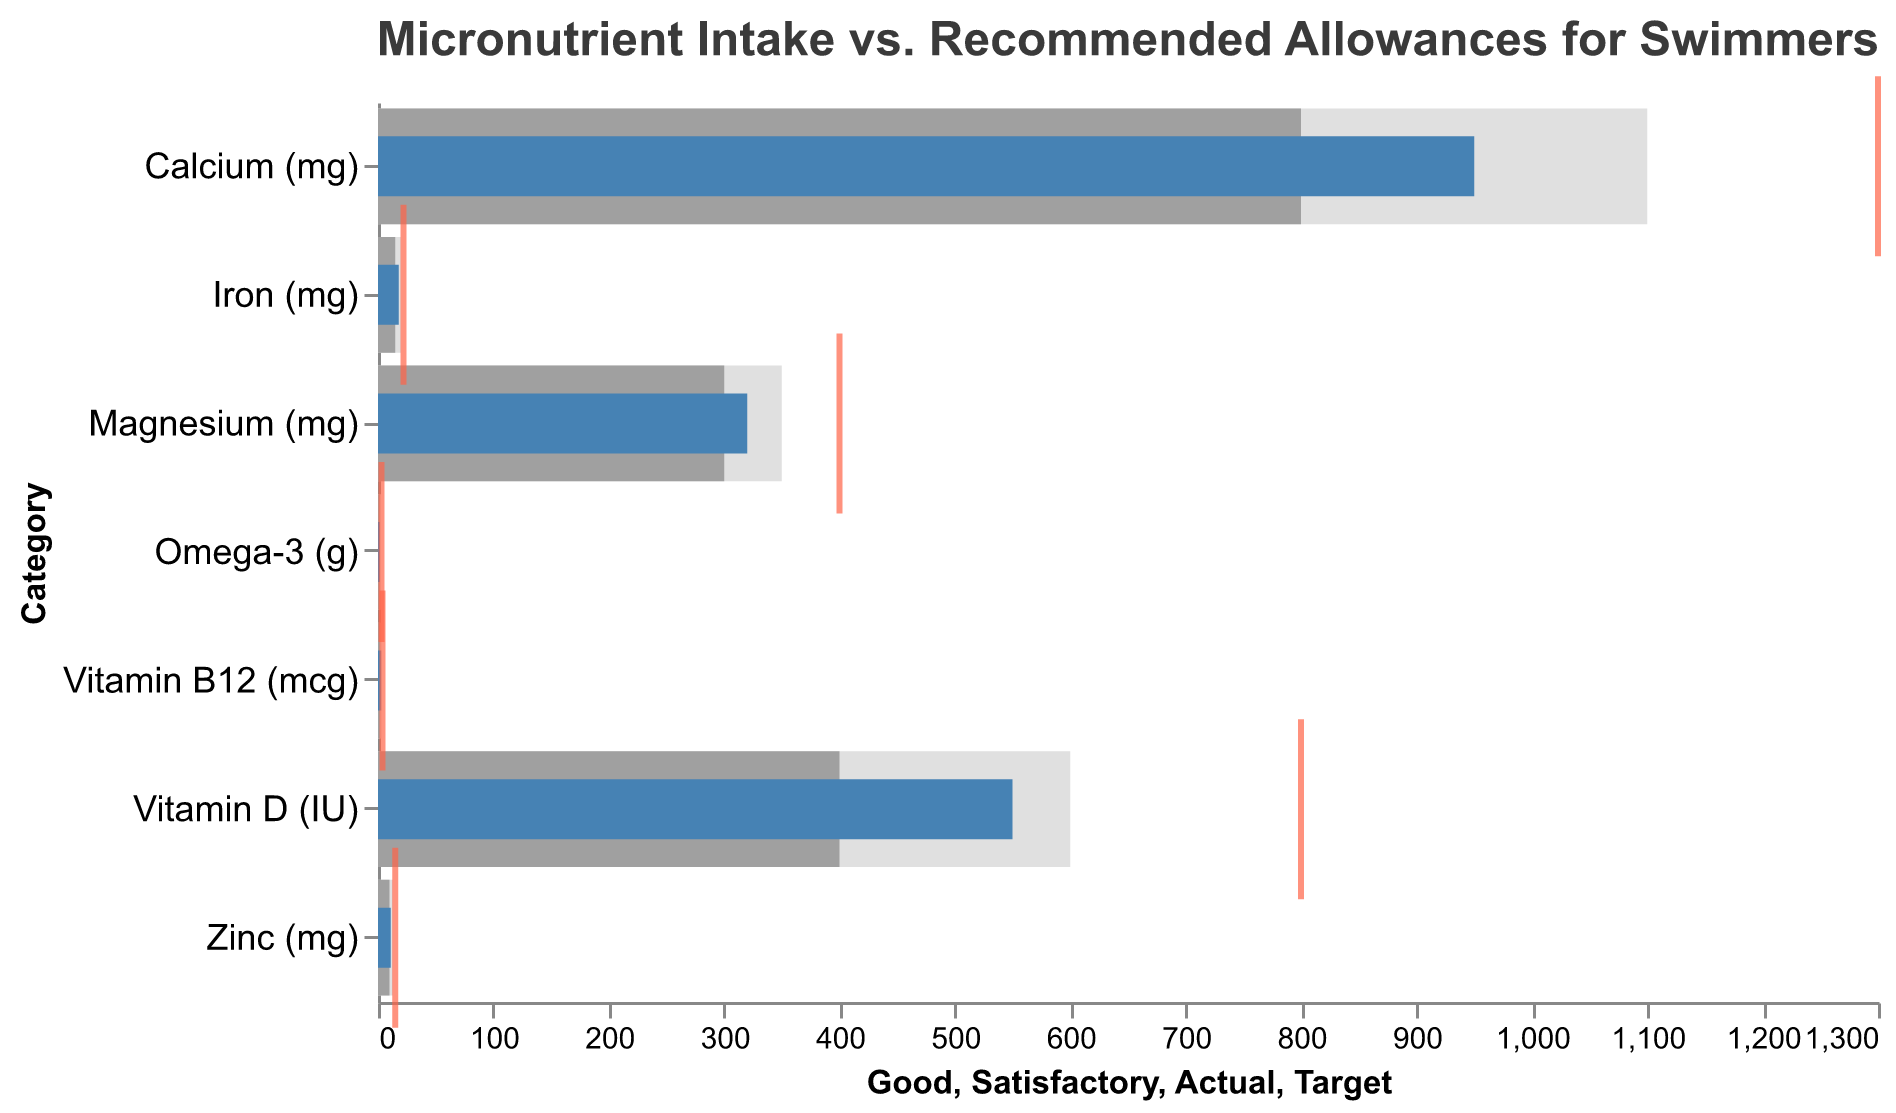What is the actual intake of Vitamin D compared to its target? The actual intake of Vitamin D is 550 IU, whereas the target is 800 IU. To determine this, look at the "Actual" and "Target" values for Vitamin D.
Answer: 550 vs. 800 Is the actual intake of Iron above or below its satisfactory level? The actual intake of Iron is 18 mg, and the satisfactory level is 15 mg. Since 18 mg is greater than 15 mg, the actual intake is above the satisfactory level.
Answer: Above How many micronutrients meet or exceed the "Good" threshold? Examine each micronutrient category and compare the actual intake values with their respective "Good" threshold. None of the micronutrients have actual intake values that meet or exceed the "Good" thresholds.
Answer: 0 Which micronutrient has the largest gap between actual intake and target value? Calculate the difference between the actual intake and target value for each micronutrient. Calcium has the largest gap: 1300 mg (target) - 950 mg (actual) = 350 mg.
Answer: Calcium What is the difference between the Iron intake and its satisfactory level? The satisfactory level of Iron is 15 mg, and the actual intake is 18 mg. Subtract the satisfactory level from the actual intake: 18 mg - 15 mg = 3 mg.
Answer: 3 mg Which micronutrient has an actual intake closest to its target value? Compare the differences between actual intake and target values for each micronutrient. Magnesium has the smallest difference: 400 mg (target) - 320 mg (actual) = 80 mg.
Answer: Magnesium Is the intake of Vitamin B12 within the good range? The good range for Vitamin B12 is between 2 and 3 mcg. The actual intake is 2.8 mcg, which falls within this range.
Answer: Yes How many micronutrients fall within the satisfactory range but below the good range? Check each micronutrient to see if the actual intake is between the satisfactory and good thresholds. Four micronutrients (Iron, Calcium, Magnesium, and Zinc) fall within this range.
Answer: 4 Which micronutrient's actual intake is the farthest from its satisfactory level? Calculate the difference between the actual intake and satisfactory level for each micronutrient. Vitamin D has the difference of 150 IU (550 - 400).
Answer: Vitamin D What is the sum of the actual intakes of Omega-3 and Zinc? Add the actual intakes of Omega-3 (1.8 g) and Zinc (11 mg): 1.8 g + 11 mg = 12.8 g if converted into the same unit.
Answer: 12.8 (total units depend on conversion) 